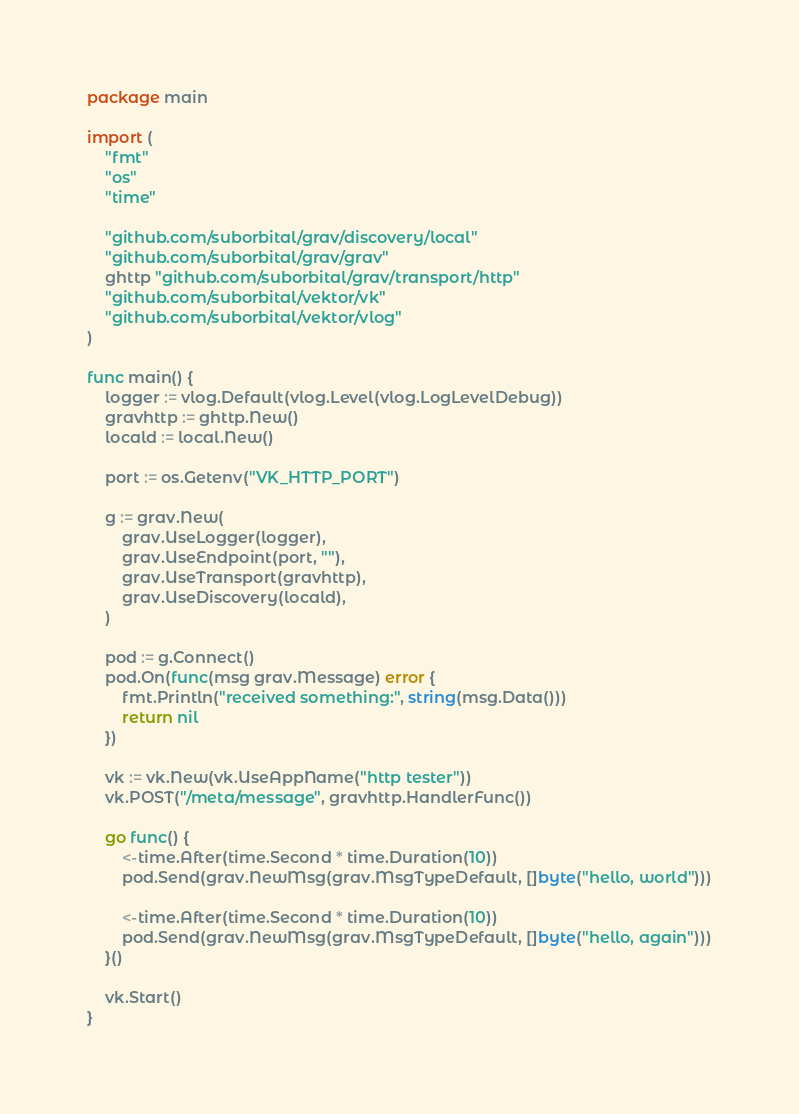Convert code to text. <code><loc_0><loc_0><loc_500><loc_500><_Go_>package main

import (
	"fmt"
	"os"
	"time"

	"github.com/suborbital/grav/discovery/local"
	"github.com/suborbital/grav/grav"
	ghttp "github.com/suborbital/grav/transport/http"
	"github.com/suborbital/vektor/vk"
	"github.com/suborbital/vektor/vlog"
)

func main() {
	logger := vlog.Default(vlog.Level(vlog.LogLevelDebug))
	gravhttp := ghttp.New()
	locald := local.New()

	port := os.Getenv("VK_HTTP_PORT")

	g := grav.New(
		grav.UseLogger(logger),
		grav.UseEndpoint(port, ""),
		grav.UseTransport(gravhttp),
		grav.UseDiscovery(locald),
	)

	pod := g.Connect()
	pod.On(func(msg grav.Message) error {
		fmt.Println("received something:", string(msg.Data()))
		return nil
	})

	vk := vk.New(vk.UseAppName("http tester"))
	vk.POST("/meta/message", gravhttp.HandlerFunc())

	go func() {
		<-time.After(time.Second * time.Duration(10))
		pod.Send(grav.NewMsg(grav.MsgTypeDefault, []byte("hello, world")))

		<-time.After(time.Second * time.Duration(10))
		pod.Send(grav.NewMsg(grav.MsgTypeDefault, []byte("hello, again")))
	}()

	vk.Start()
}
</code> 